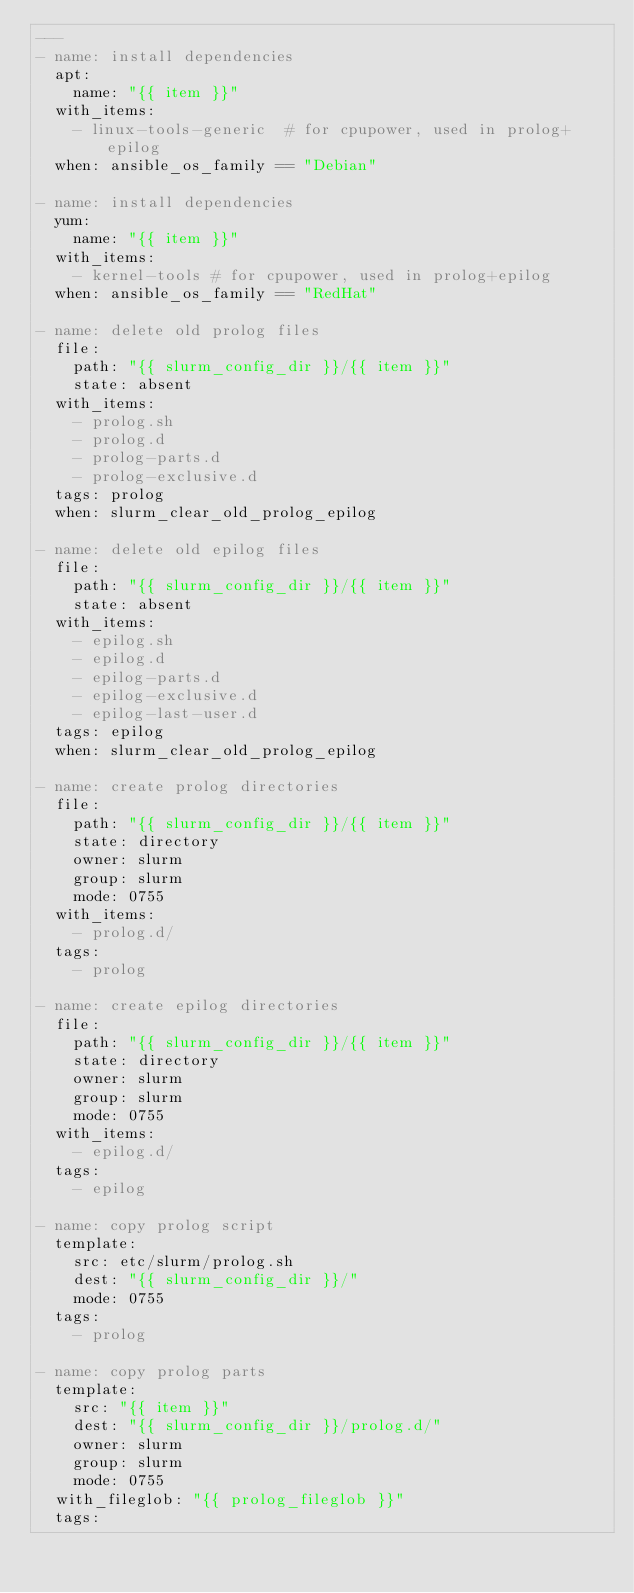<code> <loc_0><loc_0><loc_500><loc_500><_YAML_>---
- name: install dependencies
  apt:
    name: "{{ item }}"
  with_items:
    - linux-tools-generic  # for cpupower, used in prolog+epilog
  when: ansible_os_family == "Debian"

- name: install dependencies
  yum:
    name: "{{ item }}"
  with_items:
    - kernel-tools # for cpupower, used in prolog+epilog
  when: ansible_os_family == "RedHat"

- name: delete old prolog files
  file:
    path: "{{ slurm_config_dir }}/{{ item }}"
    state: absent
  with_items:
    - prolog.sh
    - prolog.d
    - prolog-parts.d
    - prolog-exclusive.d
  tags: prolog
  when: slurm_clear_old_prolog_epilog

- name: delete old epilog files
  file:
    path: "{{ slurm_config_dir }}/{{ item }}"
    state: absent
  with_items:
    - epilog.sh
    - epilog.d
    - epilog-parts.d
    - epilog-exclusive.d
    - epilog-last-user.d
  tags: epilog
  when: slurm_clear_old_prolog_epilog

- name: create prolog directories
  file:
    path: "{{ slurm_config_dir }}/{{ item }}"
    state: directory
    owner: slurm
    group: slurm
    mode: 0755
  with_items:
    - prolog.d/
  tags:
    - prolog

- name: create epilog directories
  file:
    path: "{{ slurm_config_dir }}/{{ item }}"
    state: directory
    owner: slurm
    group: slurm
    mode: 0755
  with_items:
    - epilog.d/
  tags:
    - epilog

- name: copy prolog script
  template:
    src: etc/slurm/prolog.sh
    dest: "{{ slurm_config_dir }}/"
    mode: 0755
  tags:
    - prolog

- name: copy prolog parts
  template:
    src: "{{ item }}"
    dest: "{{ slurm_config_dir }}/prolog.d/"
    owner: slurm
    group: slurm
    mode: 0755
  with_fileglob: "{{ prolog_fileglob }}"
  tags:</code> 